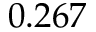<formula> <loc_0><loc_0><loc_500><loc_500>0 . 2 6 7</formula> 